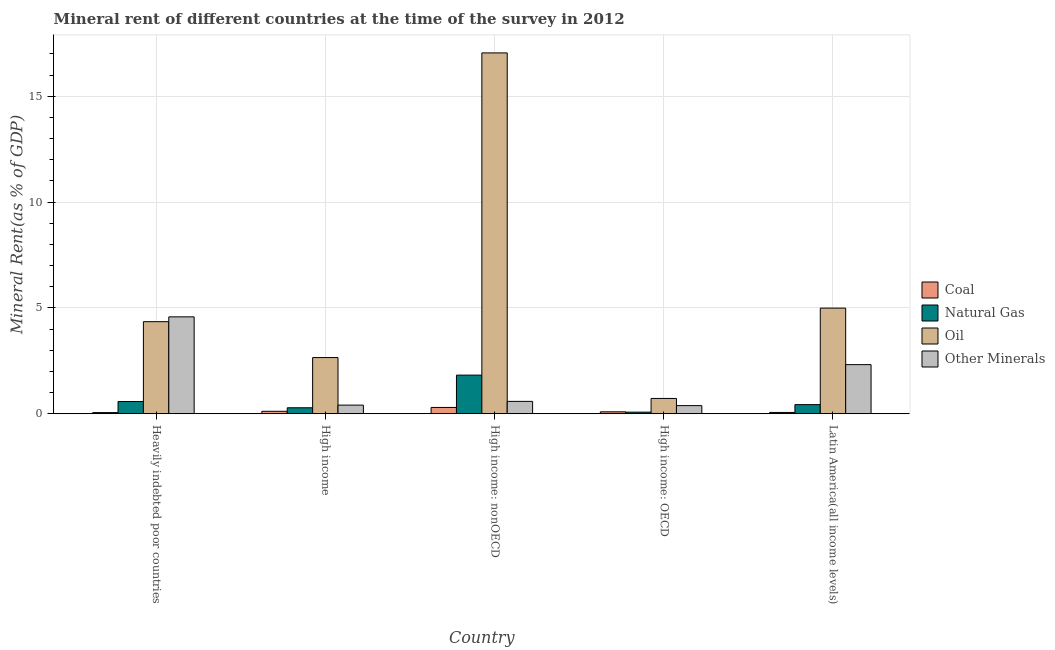How many different coloured bars are there?
Keep it short and to the point. 4. How many groups of bars are there?
Provide a short and direct response. 5. Are the number of bars per tick equal to the number of legend labels?
Make the answer very short. Yes. How many bars are there on the 5th tick from the right?
Ensure brevity in your answer.  4. What is the label of the 4th group of bars from the left?
Your answer should be very brief. High income: OECD. In how many cases, is the number of bars for a given country not equal to the number of legend labels?
Offer a very short reply. 0. What is the coal rent in High income: OECD?
Your answer should be compact. 0.09. Across all countries, what is the maximum  rent of other minerals?
Your answer should be compact. 4.58. Across all countries, what is the minimum  rent of other minerals?
Keep it short and to the point. 0.38. In which country was the oil rent maximum?
Provide a succinct answer. High income: nonOECD. In which country was the coal rent minimum?
Offer a terse response. Heavily indebted poor countries. What is the total oil rent in the graph?
Offer a very short reply. 29.76. What is the difference between the  rent of other minerals in High income: OECD and that in High income: nonOECD?
Offer a terse response. -0.2. What is the difference between the natural gas rent in High income: OECD and the coal rent in Latin America(all income levels)?
Offer a terse response. 0.01. What is the average natural gas rent per country?
Keep it short and to the point. 0.64. What is the difference between the oil rent and coal rent in High income: OECD?
Give a very brief answer. 0.63. What is the ratio of the oil rent in Heavily indebted poor countries to that in High income: OECD?
Make the answer very short. 6.02. Is the  rent of other minerals in High income: OECD less than that in Latin America(all income levels)?
Provide a short and direct response. Yes. Is the difference between the natural gas rent in High income: nonOECD and Latin America(all income levels) greater than the difference between the coal rent in High income: nonOECD and Latin America(all income levels)?
Give a very brief answer. Yes. What is the difference between the highest and the second highest oil rent?
Provide a succinct answer. 12.06. What is the difference between the highest and the lowest  rent of other minerals?
Give a very brief answer. 4.19. Is the sum of the natural gas rent in High income: nonOECD and Latin America(all income levels) greater than the maximum  rent of other minerals across all countries?
Keep it short and to the point. No. Is it the case that in every country, the sum of the coal rent and  rent of other minerals is greater than the sum of oil rent and natural gas rent?
Offer a very short reply. Yes. What does the 3rd bar from the left in Latin America(all income levels) represents?
Provide a short and direct response. Oil. What does the 1st bar from the right in High income: OECD represents?
Make the answer very short. Other Minerals. How many countries are there in the graph?
Offer a terse response. 5. What is the difference between two consecutive major ticks on the Y-axis?
Offer a very short reply. 5. Are the values on the major ticks of Y-axis written in scientific E-notation?
Offer a terse response. No. Does the graph contain any zero values?
Give a very brief answer. No. How many legend labels are there?
Provide a short and direct response. 4. How are the legend labels stacked?
Ensure brevity in your answer.  Vertical. What is the title of the graph?
Offer a very short reply. Mineral rent of different countries at the time of the survey in 2012. Does "UNHCR" appear as one of the legend labels in the graph?
Your answer should be compact. No. What is the label or title of the Y-axis?
Offer a terse response. Mineral Rent(as % of GDP). What is the Mineral Rent(as % of GDP) of Coal in Heavily indebted poor countries?
Make the answer very short. 0.05. What is the Mineral Rent(as % of GDP) of Natural Gas in Heavily indebted poor countries?
Provide a succinct answer. 0.58. What is the Mineral Rent(as % of GDP) of Oil in Heavily indebted poor countries?
Provide a succinct answer. 4.35. What is the Mineral Rent(as % of GDP) in Other Minerals in Heavily indebted poor countries?
Offer a very short reply. 4.58. What is the Mineral Rent(as % of GDP) of Coal in High income?
Your answer should be compact. 0.12. What is the Mineral Rent(as % of GDP) in Natural Gas in High income?
Provide a succinct answer. 0.28. What is the Mineral Rent(as % of GDP) of Oil in High income?
Ensure brevity in your answer.  2.65. What is the Mineral Rent(as % of GDP) of Other Minerals in High income?
Provide a short and direct response. 0.41. What is the Mineral Rent(as % of GDP) of Coal in High income: nonOECD?
Offer a very short reply. 0.3. What is the Mineral Rent(as % of GDP) of Natural Gas in High income: nonOECD?
Provide a succinct answer. 1.82. What is the Mineral Rent(as % of GDP) in Oil in High income: nonOECD?
Provide a succinct answer. 17.04. What is the Mineral Rent(as % of GDP) of Other Minerals in High income: nonOECD?
Provide a short and direct response. 0.58. What is the Mineral Rent(as % of GDP) of Coal in High income: OECD?
Offer a very short reply. 0.09. What is the Mineral Rent(as % of GDP) in Natural Gas in High income: OECD?
Your response must be concise. 0.08. What is the Mineral Rent(as % of GDP) of Oil in High income: OECD?
Make the answer very short. 0.72. What is the Mineral Rent(as % of GDP) in Other Minerals in High income: OECD?
Keep it short and to the point. 0.38. What is the Mineral Rent(as % of GDP) in Coal in Latin America(all income levels)?
Give a very brief answer. 0.06. What is the Mineral Rent(as % of GDP) in Natural Gas in Latin America(all income levels)?
Your answer should be compact. 0.43. What is the Mineral Rent(as % of GDP) in Oil in Latin America(all income levels)?
Ensure brevity in your answer.  4.99. What is the Mineral Rent(as % of GDP) in Other Minerals in Latin America(all income levels)?
Offer a terse response. 2.32. Across all countries, what is the maximum Mineral Rent(as % of GDP) of Coal?
Offer a terse response. 0.3. Across all countries, what is the maximum Mineral Rent(as % of GDP) in Natural Gas?
Offer a very short reply. 1.82. Across all countries, what is the maximum Mineral Rent(as % of GDP) in Oil?
Keep it short and to the point. 17.04. Across all countries, what is the maximum Mineral Rent(as % of GDP) in Other Minerals?
Provide a short and direct response. 4.58. Across all countries, what is the minimum Mineral Rent(as % of GDP) in Coal?
Give a very brief answer. 0.05. Across all countries, what is the minimum Mineral Rent(as % of GDP) of Natural Gas?
Offer a very short reply. 0.08. Across all countries, what is the minimum Mineral Rent(as % of GDP) in Oil?
Your answer should be compact. 0.72. Across all countries, what is the minimum Mineral Rent(as % of GDP) of Other Minerals?
Keep it short and to the point. 0.38. What is the total Mineral Rent(as % of GDP) of Coal in the graph?
Offer a terse response. 0.62. What is the total Mineral Rent(as % of GDP) of Natural Gas in the graph?
Offer a very short reply. 3.19. What is the total Mineral Rent(as % of GDP) of Oil in the graph?
Your answer should be very brief. 29.76. What is the total Mineral Rent(as % of GDP) in Other Minerals in the graph?
Offer a very short reply. 8.27. What is the difference between the Mineral Rent(as % of GDP) in Coal in Heavily indebted poor countries and that in High income?
Offer a terse response. -0.06. What is the difference between the Mineral Rent(as % of GDP) in Natural Gas in Heavily indebted poor countries and that in High income?
Your response must be concise. 0.29. What is the difference between the Mineral Rent(as % of GDP) of Oil in Heavily indebted poor countries and that in High income?
Keep it short and to the point. 1.69. What is the difference between the Mineral Rent(as % of GDP) of Other Minerals in Heavily indebted poor countries and that in High income?
Offer a terse response. 4.17. What is the difference between the Mineral Rent(as % of GDP) in Coal in Heavily indebted poor countries and that in High income: nonOECD?
Your answer should be compact. -0.24. What is the difference between the Mineral Rent(as % of GDP) of Natural Gas in Heavily indebted poor countries and that in High income: nonOECD?
Make the answer very short. -1.25. What is the difference between the Mineral Rent(as % of GDP) in Oil in Heavily indebted poor countries and that in High income: nonOECD?
Make the answer very short. -12.7. What is the difference between the Mineral Rent(as % of GDP) in Other Minerals in Heavily indebted poor countries and that in High income: nonOECD?
Your answer should be compact. 3.99. What is the difference between the Mineral Rent(as % of GDP) in Coal in Heavily indebted poor countries and that in High income: OECD?
Provide a short and direct response. -0.04. What is the difference between the Mineral Rent(as % of GDP) of Natural Gas in Heavily indebted poor countries and that in High income: OECD?
Offer a terse response. 0.5. What is the difference between the Mineral Rent(as % of GDP) in Oil in Heavily indebted poor countries and that in High income: OECD?
Offer a very short reply. 3.63. What is the difference between the Mineral Rent(as % of GDP) of Other Minerals in Heavily indebted poor countries and that in High income: OECD?
Offer a terse response. 4.19. What is the difference between the Mineral Rent(as % of GDP) of Coal in Heavily indebted poor countries and that in Latin America(all income levels)?
Provide a short and direct response. -0.01. What is the difference between the Mineral Rent(as % of GDP) in Natural Gas in Heavily indebted poor countries and that in Latin America(all income levels)?
Your answer should be compact. 0.15. What is the difference between the Mineral Rent(as % of GDP) in Oil in Heavily indebted poor countries and that in Latin America(all income levels)?
Offer a terse response. -0.64. What is the difference between the Mineral Rent(as % of GDP) of Other Minerals in Heavily indebted poor countries and that in Latin America(all income levels)?
Give a very brief answer. 2.26. What is the difference between the Mineral Rent(as % of GDP) in Coal in High income and that in High income: nonOECD?
Make the answer very short. -0.18. What is the difference between the Mineral Rent(as % of GDP) of Natural Gas in High income and that in High income: nonOECD?
Give a very brief answer. -1.54. What is the difference between the Mineral Rent(as % of GDP) in Oil in High income and that in High income: nonOECD?
Provide a succinct answer. -14.39. What is the difference between the Mineral Rent(as % of GDP) in Other Minerals in High income and that in High income: nonOECD?
Offer a very short reply. -0.18. What is the difference between the Mineral Rent(as % of GDP) in Coal in High income and that in High income: OECD?
Make the answer very short. 0.02. What is the difference between the Mineral Rent(as % of GDP) in Natural Gas in High income and that in High income: OECD?
Offer a very short reply. 0.21. What is the difference between the Mineral Rent(as % of GDP) in Oil in High income and that in High income: OECD?
Provide a succinct answer. 1.93. What is the difference between the Mineral Rent(as % of GDP) in Other Minerals in High income and that in High income: OECD?
Offer a terse response. 0.02. What is the difference between the Mineral Rent(as % of GDP) in Coal in High income and that in Latin America(all income levels)?
Offer a terse response. 0.05. What is the difference between the Mineral Rent(as % of GDP) in Natural Gas in High income and that in Latin America(all income levels)?
Provide a short and direct response. -0.15. What is the difference between the Mineral Rent(as % of GDP) in Oil in High income and that in Latin America(all income levels)?
Offer a very short reply. -2.34. What is the difference between the Mineral Rent(as % of GDP) in Other Minerals in High income and that in Latin America(all income levels)?
Provide a short and direct response. -1.91. What is the difference between the Mineral Rent(as % of GDP) of Coal in High income: nonOECD and that in High income: OECD?
Ensure brevity in your answer.  0.21. What is the difference between the Mineral Rent(as % of GDP) of Natural Gas in High income: nonOECD and that in High income: OECD?
Keep it short and to the point. 1.75. What is the difference between the Mineral Rent(as % of GDP) of Oil in High income: nonOECD and that in High income: OECD?
Give a very brief answer. 16.32. What is the difference between the Mineral Rent(as % of GDP) in Other Minerals in High income: nonOECD and that in High income: OECD?
Offer a very short reply. 0.2. What is the difference between the Mineral Rent(as % of GDP) in Coal in High income: nonOECD and that in Latin America(all income levels)?
Provide a short and direct response. 0.24. What is the difference between the Mineral Rent(as % of GDP) of Natural Gas in High income: nonOECD and that in Latin America(all income levels)?
Ensure brevity in your answer.  1.39. What is the difference between the Mineral Rent(as % of GDP) of Oil in High income: nonOECD and that in Latin America(all income levels)?
Your answer should be very brief. 12.06. What is the difference between the Mineral Rent(as % of GDP) of Other Minerals in High income: nonOECD and that in Latin America(all income levels)?
Give a very brief answer. -1.74. What is the difference between the Mineral Rent(as % of GDP) in Coal in High income: OECD and that in Latin America(all income levels)?
Your answer should be very brief. 0.03. What is the difference between the Mineral Rent(as % of GDP) of Natural Gas in High income: OECD and that in Latin America(all income levels)?
Offer a terse response. -0.36. What is the difference between the Mineral Rent(as % of GDP) of Oil in High income: OECD and that in Latin America(all income levels)?
Provide a short and direct response. -4.27. What is the difference between the Mineral Rent(as % of GDP) in Other Minerals in High income: OECD and that in Latin America(all income levels)?
Give a very brief answer. -1.94. What is the difference between the Mineral Rent(as % of GDP) of Coal in Heavily indebted poor countries and the Mineral Rent(as % of GDP) of Natural Gas in High income?
Your answer should be compact. -0.23. What is the difference between the Mineral Rent(as % of GDP) in Coal in Heavily indebted poor countries and the Mineral Rent(as % of GDP) in Oil in High income?
Your response must be concise. -2.6. What is the difference between the Mineral Rent(as % of GDP) of Coal in Heavily indebted poor countries and the Mineral Rent(as % of GDP) of Other Minerals in High income?
Make the answer very short. -0.35. What is the difference between the Mineral Rent(as % of GDP) of Natural Gas in Heavily indebted poor countries and the Mineral Rent(as % of GDP) of Oil in High income?
Your response must be concise. -2.08. What is the difference between the Mineral Rent(as % of GDP) of Natural Gas in Heavily indebted poor countries and the Mineral Rent(as % of GDP) of Other Minerals in High income?
Keep it short and to the point. 0.17. What is the difference between the Mineral Rent(as % of GDP) of Oil in Heavily indebted poor countries and the Mineral Rent(as % of GDP) of Other Minerals in High income?
Ensure brevity in your answer.  3.94. What is the difference between the Mineral Rent(as % of GDP) of Coal in Heavily indebted poor countries and the Mineral Rent(as % of GDP) of Natural Gas in High income: nonOECD?
Your answer should be very brief. -1.77. What is the difference between the Mineral Rent(as % of GDP) in Coal in Heavily indebted poor countries and the Mineral Rent(as % of GDP) in Oil in High income: nonOECD?
Your response must be concise. -16.99. What is the difference between the Mineral Rent(as % of GDP) in Coal in Heavily indebted poor countries and the Mineral Rent(as % of GDP) in Other Minerals in High income: nonOECD?
Make the answer very short. -0.53. What is the difference between the Mineral Rent(as % of GDP) of Natural Gas in Heavily indebted poor countries and the Mineral Rent(as % of GDP) of Oil in High income: nonOECD?
Offer a terse response. -16.47. What is the difference between the Mineral Rent(as % of GDP) of Natural Gas in Heavily indebted poor countries and the Mineral Rent(as % of GDP) of Other Minerals in High income: nonOECD?
Your response must be concise. -0.01. What is the difference between the Mineral Rent(as % of GDP) in Oil in Heavily indebted poor countries and the Mineral Rent(as % of GDP) in Other Minerals in High income: nonOECD?
Your answer should be compact. 3.76. What is the difference between the Mineral Rent(as % of GDP) in Coal in Heavily indebted poor countries and the Mineral Rent(as % of GDP) in Natural Gas in High income: OECD?
Keep it short and to the point. -0.02. What is the difference between the Mineral Rent(as % of GDP) of Coal in Heavily indebted poor countries and the Mineral Rent(as % of GDP) of Oil in High income: OECD?
Your response must be concise. -0.67. What is the difference between the Mineral Rent(as % of GDP) of Coal in Heavily indebted poor countries and the Mineral Rent(as % of GDP) of Other Minerals in High income: OECD?
Give a very brief answer. -0.33. What is the difference between the Mineral Rent(as % of GDP) in Natural Gas in Heavily indebted poor countries and the Mineral Rent(as % of GDP) in Oil in High income: OECD?
Provide a short and direct response. -0.15. What is the difference between the Mineral Rent(as % of GDP) in Natural Gas in Heavily indebted poor countries and the Mineral Rent(as % of GDP) in Other Minerals in High income: OECD?
Your answer should be compact. 0.19. What is the difference between the Mineral Rent(as % of GDP) in Oil in Heavily indebted poor countries and the Mineral Rent(as % of GDP) in Other Minerals in High income: OECD?
Your response must be concise. 3.96. What is the difference between the Mineral Rent(as % of GDP) of Coal in Heavily indebted poor countries and the Mineral Rent(as % of GDP) of Natural Gas in Latin America(all income levels)?
Your response must be concise. -0.38. What is the difference between the Mineral Rent(as % of GDP) in Coal in Heavily indebted poor countries and the Mineral Rent(as % of GDP) in Oil in Latin America(all income levels)?
Your answer should be compact. -4.93. What is the difference between the Mineral Rent(as % of GDP) in Coal in Heavily indebted poor countries and the Mineral Rent(as % of GDP) in Other Minerals in Latin America(all income levels)?
Provide a succinct answer. -2.27. What is the difference between the Mineral Rent(as % of GDP) in Natural Gas in Heavily indebted poor countries and the Mineral Rent(as % of GDP) in Oil in Latin America(all income levels)?
Make the answer very short. -4.41. What is the difference between the Mineral Rent(as % of GDP) of Natural Gas in Heavily indebted poor countries and the Mineral Rent(as % of GDP) of Other Minerals in Latin America(all income levels)?
Ensure brevity in your answer.  -1.74. What is the difference between the Mineral Rent(as % of GDP) in Oil in Heavily indebted poor countries and the Mineral Rent(as % of GDP) in Other Minerals in Latin America(all income levels)?
Provide a succinct answer. 2.03. What is the difference between the Mineral Rent(as % of GDP) of Coal in High income and the Mineral Rent(as % of GDP) of Natural Gas in High income: nonOECD?
Offer a terse response. -1.71. What is the difference between the Mineral Rent(as % of GDP) of Coal in High income and the Mineral Rent(as % of GDP) of Oil in High income: nonOECD?
Make the answer very short. -16.93. What is the difference between the Mineral Rent(as % of GDP) of Coal in High income and the Mineral Rent(as % of GDP) of Other Minerals in High income: nonOECD?
Provide a succinct answer. -0.47. What is the difference between the Mineral Rent(as % of GDP) in Natural Gas in High income and the Mineral Rent(as % of GDP) in Oil in High income: nonOECD?
Make the answer very short. -16.76. What is the difference between the Mineral Rent(as % of GDP) in Natural Gas in High income and the Mineral Rent(as % of GDP) in Other Minerals in High income: nonOECD?
Give a very brief answer. -0.3. What is the difference between the Mineral Rent(as % of GDP) in Oil in High income and the Mineral Rent(as % of GDP) in Other Minerals in High income: nonOECD?
Offer a terse response. 2.07. What is the difference between the Mineral Rent(as % of GDP) of Coal in High income and the Mineral Rent(as % of GDP) of Natural Gas in High income: OECD?
Give a very brief answer. 0.04. What is the difference between the Mineral Rent(as % of GDP) of Coal in High income and the Mineral Rent(as % of GDP) of Oil in High income: OECD?
Offer a very short reply. -0.61. What is the difference between the Mineral Rent(as % of GDP) of Coal in High income and the Mineral Rent(as % of GDP) of Other Minerals in High income: OECD?
Give a very brief answer. -0.27. What is the difference between the Mineral Rent(as % of GDP) in Natural Gas in High income and the Mineral Rent(as % of GDP) in Oil in High income: OECD?
Offer a very short reply. -0.44. What is the difference between the Mineral Rent(as % of GDP) of Natural Gas in High income and the Mineral Rent(as % of GDP) of Other Minerals in High income: OECD?
Ensure brevity in your answer.  -0.1. What is the difference between the Mineral Rent(as % of GDP) in Oil in High income and the Mineral Rent(as % of GDP) in Other Minerals in High income: OECD?
Offer a very short reply. 2.27. What is the difference between the Mineral Rent(as % of GDP) in Coal in High income and the Mineral Rent(as % of GDP) in Natural Gas in Latin America(all income levels)?
Offer a very short reply. -0.32. What is the difference between the Mineral Rent(as % of GDP) of Coal in High income and the Mineral Rent(as % of GDP) of Oil in Latin America(all income levels)?
Provide a short and direct response. -4.87. What is the difference between the Mineral Rent(as % of GDP) in Coal in High income and the Mineral Rent(as % of GDP) in Other Minerals in Latin America(all income levels)?
Give a very brief answer. -2.2. What is the difference between the Mineral Rent(as % of GDP) of Natural Gas in High income and the Mineral Rent(as % of GDP) of Oil in Latin America(all income levels)?
Offer a terse response. -4.71. What is the difference between the Mineral Rent(as % of GDP) of Natural Gas in High income and the Mineral Rent(as % of GDP) of Other Minerals in Latin America(all income levels)?
Make the answer very short. -2.04. What is the difference between the Mineral Rent(as % of GDP) in Oil in High income and the Mineral Rent(as % of GDP) in Other Minerals in Latin America(all income levels)?
Provide a short and direct response. 0.33. What is the difference between the Mineral Rent(as % of GDP) of Coal in High income: nonOECD and the Mineral Rent(as % of GDP) of Natural Gas in High income: OECD?
Provide a succinct answer. 0.22. What is the difference between the Mineral Rent(as % of GDP) in Coal in High income: nonOECD and the Mineral Rent(as % of GDP) in Oil in High income: OECD?
Ensure brevity in your answer.  -0.43. What is the difference between the Mineral Rent(as % of GDP) in Coal in High income: nonOECD and the Mineral Rent(as % of GDP) in Other Minerals in High income: OECD?
Your response must be concise. -0.09. What is the difference between the Mineral Rent(as % of GDP) in Natural Gas in High income: nonOECD and the Mineral Rent(as % of GDP) in Oil in High income: OECD?
Offer a very short reply. 1.1. What is the difference between the Mineral Rent(as % of GDP) in Natural Gas in High income: nonOECD and the Mineral Rent(as % of GDP) in Other Minerals in High income: OECD?
Ensure brevity in your answer.  1.44. What is the difference between the Mineral Rent(as % of GDP) in Oil in High income: nonOECD and the Mineral Rent(as % of GDP) in Other Minerals in High income: OECD?
Provide a short and direct response. 16.66. What is the difference between the Mineral Rent(as % of GDP) of Coal in High income: nonOECD and the Mineral Rent(as % of GDP) of Natural Gas in Latin America(all income levels)?
Offer a very short reply. -0.13. What is the difference between the Mineral Rent(as % of GDP) of Coal in High income: nonOECD and the Mineral Rent(as % of GDP) of Oil in Latin America(all income levels)?
Provide a short and direct response. -4.69. What is the difference between the Mineral Rent(as % of GDP) in Coal in High income: nonOECD and the Mineral Rent(as % of GDP) in Other Minerals in Latin America(all income levels)?
Your answer should be compact. -2.02. What is the difference between the Mineral Rent(as % of GDP) in Natural Gas in High income: nonOECD and the Mineral Rent(as % of GDP) in Oil in Latin America(all income levels)?
Give a very brief answer. -3.17. What is the difference between the Mineral Rent(as % of GDP) of Natural Gas in High income: nonOECD and the Mineral Rent(as % of GDP) of Other Minerals in Latin America(all income levels)?
Ensure brevity in your answer.  -0.5. What is the difference between the Mineral Rent(as % of GDP) in Oil in High income: nonOECD and the Mineral Rent(as % of GDP) in Other Minerals in Latin America(all income levels)?
Your response must be concise. 14.72. What is the difference between the Mineral Rent(as % of GDP) in Coal in High income: OECD and the Mineral Rent(as % of GDP) in Natural Gas in Latin America(all income levels)?
Offer a very short reply. -0.34. What is the difference between the Mineral Rent(as % of GDP) in Coal in High income: OECD and the Mineral Rent(as % of GDP) in Oil in Latin America(all income levels)?
Keep it short and to the point. -4.9. What is the difference between the Mineral Rent(as % of GDP) of Coal in High income: OECD and the Mineral Rent(as % of GDP) of Other Minerals in Latin America(all income levels)?
Provide a short and direct response. -2.23. What is the difference between the Mineral Rent(as % of GDP) in Natural Gas in High income: OECD and the Mineral Rent(as % of GDP) in Oil in Latin America(all income levels)?
Provide a succinct answer. -4.91. What is the difference between the Mineral Rent(as % of GDP) of Natural Gas in High income: OECD and the Mineral Rent(as % of GDP) of Other Minerals in Latin America(all income levels)?
Provide a succinct answer. -2.24. What is the difference between the Mineral Rent(as % of GDP) of Oil in High income: OECD and the Mineral Rent(as % of GDP) of Other Minerals in Latin America(all income levels)?
Offer a terse response. -1.6. What is the average Mineral Rent(as % of GDP) in Coal per country?
Your answer should be very brief. 0.12. What is the average Mineral Rent(as % of GDP) of Natural Gas per country?
Your answer should be very brief. 0.64. What is the average Mineral Rent(as % of GDP) of Oil per country?
Offer a terse response. 5.95. What is the average Mineral Rent(as % of GDP) in Other Minerals per country?
Your answer should be very brief. 1.65. What is the difference between the Mineral Rent(as % of GDP) in Coal and Mineral Rent(as % of GDP) in Natural Gas in Heavily indebted poor countries?
Your answer should be compact. -0.52. What is the difference between the Mineral Rent(as % of GDP) in Coal and Mineral Rent(as % of GDP) in Oil in Heavily indebted poor countries?
Keep it short and to the point. -4.29. What is the difference between the Mineral Rent(as % of GDP) of Coal and Mineral Rent(as % of GDP) of Other Minerals in Heavily indebted poor countries?
Your response must be concise. -4.52. What is the difference between the Mineral Rent(as % of GDP) in Natural Gas and Mineral Rent(as % of GDP) in Oil in Heavily indebted poor countries?
Give a very brief answer. -3.77. What is the difference between the Mineral Rent(as % of GDP) of Natural Gas and Mineral Rent(as % of GDP) of Other Minerals in Heavily indebted poor countries?
Your answer should be very brief. -4. What is the difference between the Mineral Rent(as % of GDP) in Oil and Mineral Rent(as % of GDP) in Other Minerals in Heavily indebted poor countries?
Ensure brevity in your answer.  -0.23. What is the difference between the Mineral Rent(as % of GDP) in Coal and Mineral Rent(as % of GDP) in Natural Gas in High income?
Provide a succinct answer. -0.17. What is the difference between the Mineral Rent(as % of GDP) of Coal and Mineral Rent(as % of GDP) of Oil in High income?
Provide a succinct answer. -2.54. What is the difference between the Mineral Rent(as % of GDP) of Coal and Mineral Rent(as % of GDP) of Other Minerals in High income?
Ensure brevity in your answer.  -0.29. What is the difference between the Mineral Rent(as % of GDP) of Natural Gas and Mineral Rent(as % of GDP) of Oil in High income?
Offer a terse response. -2.37. What is the difference between the Mineral Rent(as % of GDP) of Natural Gas and Mineral Rent(as % of GDP) of Other Minerals in High income?
Your response must be concise. -0.13. What is the difference between the Mineral Rent(as % of GDP) in Oil and Mineral Rent(as % of GDP) in Other Minerals in High income?
Offer a very short reply. 2.25. What is the difference between the Mineral Rent(as % of GDP) in Coal and Mineral Rent(as % of GDP) in Natural Gas in High income: nonOECD?
Ensure brevity in your answer.  -1.53. What is the difference between the Mineral Rent(as % of GDP) of Coal and Mineral Rent(as % of GDP) of Oil in High income: nonOECD?
Offer a very short reply. -16.75. What is the difference between the Mineral Rent(as % of GDP) of Coal and Mineral Rent(as % of GDP) of Other Minerals in High income: nonOECD?
Keep it short and to the point. -0.29. What is the difference between the Mineral Rent(as % of GDP) in Natural Gas and Mineral Rent(as % of GDP) in Oil in High income: nonOECD?
Provide a short and direct response. -15.22. What is the difference between the Mineral Rent(as % of GDP) of Natural Gas and Mineral Rent(as % of GDP) of Other Minerals in High income: nonOECD?
Your response must be concise. 1.24. What is the difference between the Mineral Rent(as % of GDP) of Oil and Mineral Rent(as % of GDP) of Other Minerals in High income: nonOECD?
Provide a short and direct response. 16.46. What is the difference between the Mineral Rent(as % of GDP) of Coal and Mineral Rent(as % of GDP) of Natural Gas in High income: OECD?
Your answer should be very brief. 0.02. What is the difference between the Mineral Rent(as % of GDP) of Coal and Mineral Rent(as % of GDP) of Oil in High income: OECD?
Your response must be concise. -0.63. What is the difference between the Mineral Rent(as % of GDP) in Coal and Mineral Rent(as % of GDP) in Other Minerals in High income: OECD?
Your response must be concise. -0.29. What is the difference between the Mineral Rent(as % of GDP) of Natural Gas and Mineral Rent(as % of GDP) of Oil in High income: OECD?
Your answer should be compact. -0.65. What is the difference between the Mineral Rent(as % of GDP) of Natural Gas and Mineral Rent(as % of GDP) of Other Minerals in High income: OECD?
Provide a short and direct response. -0.31. What is the difference between the Mineral Rent(as % of GDP) in Oil and Mineral Rent(as % of GDP) in Other Minerals in High income: OECD?
Offer a very short reply. 0.34. What is the difference between the Mineral Rent(as % of GDP) in Coal and Mineral Rent(as % of GDP) in Natural Gas in Latin America(all income levels)?
Keep it short and to the point. -0.37. What is the difference between the Mineral Rent(as % of GDP) in Coal and Mineral Rent(as % of GDP) in Oil in Latin America(all income levels)?
Keep it short and to the point. -4.93. What is the difference between the Mineral Rent(as % of GDP) of Coal and Mineral Rent(as % of GDP) of Other Minerals in Latin America(all income levels)?
Provide a succinct answer. -2.26. What is the difference between the Mineral Rent(as % of GDP) in Natural Gas and Mineral Rent(as % of GDP) in Oil in Latin America(all income levels)?
Provide a succinct answer. -4.56. What is the difference between the Mineral Rent(as % of GDP) of Natural Gas and Mineral Rent(as % of GDP) of Other Minerals in Latin America(all income levels)?
Your response must be concise. -1.89. What is the difference between the Mineral Rent(as % of GDP) of Oil and Mineral Rent(as % of GDP) of Other Minerals in Latin America(all income levels)?
Offer a very short reply. 2.67. What is the ratio of the Mineral Rent(as % of GDP) of Coal in Heavily indebted poor countries to that in High income?
Offer a very short reply. 0.47. What is the ratio of the Mineral Rent(as % of GDP) of Natural Gas in Heavily indebted poor countries to that in High income?
Your answer should be very brief. 2.05. What is the ratio of the Mineral Rent(as % of GDP) in Oil in Heavily indebted poor countries to that in High income?
Ensure brevity in your answer.  1.64. What is the ratio of the Mineral Rent(as % of GDP) in Other Minerals in Heavily indebted poor countries to that in High income?
Provide a short and direct response. 11.24. What is the ratio of the Mineral Rent(as % of GDP) in Coal in Heavily indebted poor countries to that in High income: nonOECD?
Keep it short and to the point. 0.18. What is the ratio of the Mineral Rent(as % of GDP) in Natural Gas in Heavily indebted poor countries to that in High income: nonOECD?
Provide a succinct answer. 0.32. What is the ratio of the Mineral Rent(as % of GDP) of Oil in Heavily indebted poor countries to that in High income: nonOECD?
Offer a very short reply. 0.26. What is the ratio of the Mineral Rent(as % of GDP) in Other Minerals in Heavily indebted poor countries to that in High income: nonOECD?
Provide a succinct answer. 7.84. What is the ratio of the Mineral Rent(as % of GDP) of Coal in Heavily indebted poor countries to that in High income: OECD?
Ensure brevity in your answer.  0.6. What is the ratio of the Mineral Rent(as % of GDP) of Natural Gas in Heavily indebted poor countries to that in High income: OECD?
Your answer should be compact. 7.69. What is the ratio of the Mineral Rent(as % of GDP) of Oil in Heavily indebted poor countries to that in High income: OECD?
Your response must be concise. 6.02. What is the ratio of the Mineral Rent(as % of GDP) in Other Minerals in Heavily indebted poor countries to that in High income: OECD?
Make the answer very short. 11.93. What is the ratio of the Mineral Rent(as % of GDP) in Coal in Heavily indebted poor countries to that in Latin America(all income levels)?
Your answer should be very brief. 0.89. What is the ratio of the Mineral Rent(as % of GDP) of Natural Gas in Heavily indebted poor countries to that in Latin America(all income levels)?
Your answer should be compact. 1.34. What is the ratio of the Mineral Rent(as % of GDP) of Oil in Heavily indebted poor countries to that in Latin America(all income levels)?
Your response must be concise. 0.87. What is the ratio of the Mineral Rent(as % of GDP) in Other Minerals in Heavily indebted poor countries to that in Latin America(all income levels)?
Ensure brevity in your answer.  1.97. What is the ratio of the Mineral Rent(as % of GDP) in Coal in High income to that in High income: nonOECD?
Offer a very short reply. 0.39. What is the ratio of the Mineral Rent(as % of GDP) of Natural Gas in High income to that in High income: nonOECD?
Make the answer very short. 0.15. What is the ratio of the Mineral Rent(as % of GDP) of Oil in High income to that in High income: nonOECD?
Your response must be concise. 0.16. What is the ratio of the Mineral Rent(as % of GDP) of Other Minerals in High income to that in High income: nonOECD?
Offer a terse response. 0.7. What is the ratio of the Mineral Rent(as % of GDP) of Coal in High income to that in High income: OECD?
Your response must be concise. 1.27. What is the ratio of the Mineral Rent(as % of GDP) in Natural Gas in High income to that in High income: OECD?
Your answer should be very brief. 3.76. What is the ratio of the Mineral Rent(as % of GDP) of Oil in High income to that in High income: OECD?
Ensure brevity in your answer.  3.67. What is the ratio of the Mineral Rent(as % of GDP) in Other Minerals in High income to that in High income: OECD?
Your answer should be compact. 1.06. What is the ratio of the Mineral Rent(as % of GDP) in Coal in High income to that in Latin America(all income levels)?
Provide a short and direct response. 1.9. What is the ratio of the Mineral Rent(as % of GDP) in Natural Gas in High income to that in Latin America(all income levels)?
Give a very brief answer. 0.65. What is the ratio of the Mineral Rent(as % of GDP) in Oil in High income to that in Latin America(all income levels)?
Provide a short and direct response. 0.53. What is the ratio of the Mineral Rent(as % of GDP) of Other Minerals in High income to that in Latin America(all income levels)?
Your answer should be very brief. 0.18. What is the ratio of the Mineral Rent(as % of GDP) of Coal in High income: nonOECD to that in High income: OECD?
Give a very brief answer. 3.27. What is the ratio of the Mineral Rent(as % of GDP) in Natural Gas in High income: nonOECD to that in High income: OECD?
Your answer should be very brief. 24.32. What is the ratio of the Mineral Rent(as % of GDP) of Oil in High income: nonOECD to that in High income: OECD?
Provide a short and direct response. 23.6. What is the ratio of the Mineral Rent(as % of GDP) of Other Minerals in High income: nonOECD to that in High income: OECD?
Offer a terse response. 1.52. What is the ratio of the Mineral Rent(as % of GDP) of Coal in High income: nonOECD to that in Latin America(all income levels)?
Provide a succinct answer. 4.89. What is the ratio of the Mineral Rent(as % of GDP) in Natural Gas in High income: nonOECD to that in Latin America(all income levels)?
Offer a very short reply. 4.23. What is the ratio of the Mineral Rent(as % of GDP) in Oil in High income: nonOECD to that in Latin America(all income levels)?
Your answer should be compact. 3.42. What is the ratio of the Mineral Rent(as % of GDP) in Other Minerals in High income: nonOECD to that in Latin America(all income levels)?
Offer a terse response. 0.25. What is the ratio of the Mineral Rent(as % of GDP) of Coal in High income: OECD to that in Latin America(all income levels)?
Offer a very short reply. 1.5. What is the ratio of the Mineral Rent(as % of GDP) of Natural Gas in High income: OECD to that in Latin America(all income levels)?
Provide a short and direct response. 0.17. What is the ratio of the Mineral Rent(as % of GDP) in Oil in High income: OECD to that in Latin America(all income levels)?
Make the answer very short. 0.14. What is the ratio of the Mineral Rent(as % of GDP) of Other Minerals in High income: OECD to that in Latin America(all income levels)?
Give a very brief answer. 0.17. What is the difference between the highest and the second highest Mineral Rent(as % of GDP) in Coal?
Offer a terse response. 0.18. What is the difference between the highest and the second highest Mineral Rent(as % of GDP) in Natural Gas?
Provide a succinct answer. 1.25. What is the difference between the highest and the second highest Mineral Rent(as % of GDP) of Oil?
Ensure brevity in your answer.  12.06. What is the difference between the highest and the second highest Mineral Rent(as % of GDP) of Other Minerals?
Your answer should be compact. 2.26. What is the difference between the highest and the lowest Mineral Rent(as % of GDP) in Coal?
Make the answer very short. 0.24. What is the difference between the highest and the lowest Mineral Rent(as % of GDP) in Natural Gas?
Make the answer very short. 1.75. What is the difference between the highest and the lowest Mineral Rent(as % of GDP) in Oil?
Offer a very short reply. 16.32. What is the difference between the highest and the lowest Mineral Rent(as % of GDP) of Other Minerals?
Your answer should be compact. 4.19. 